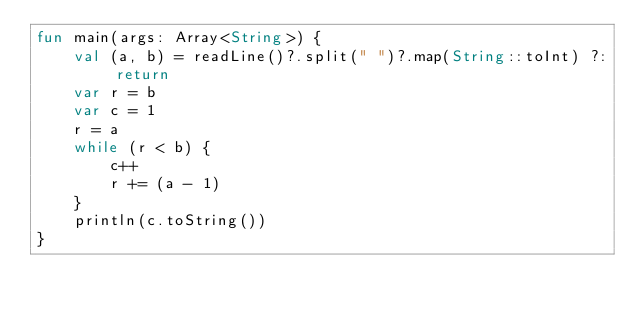<code> <loc_0><loc_0><loc_500><loc_500><_Kotlin_>fun main(args: Array<String>) {
    val (a, b) = readLine()?.split(" ")?.map(String::toInt) ?: return
    var r = b
    var c = 1
    r = a
    while (r < b) {
        c++
        r += (a - 1)
    }
    println(c.toString())
}
</code> 